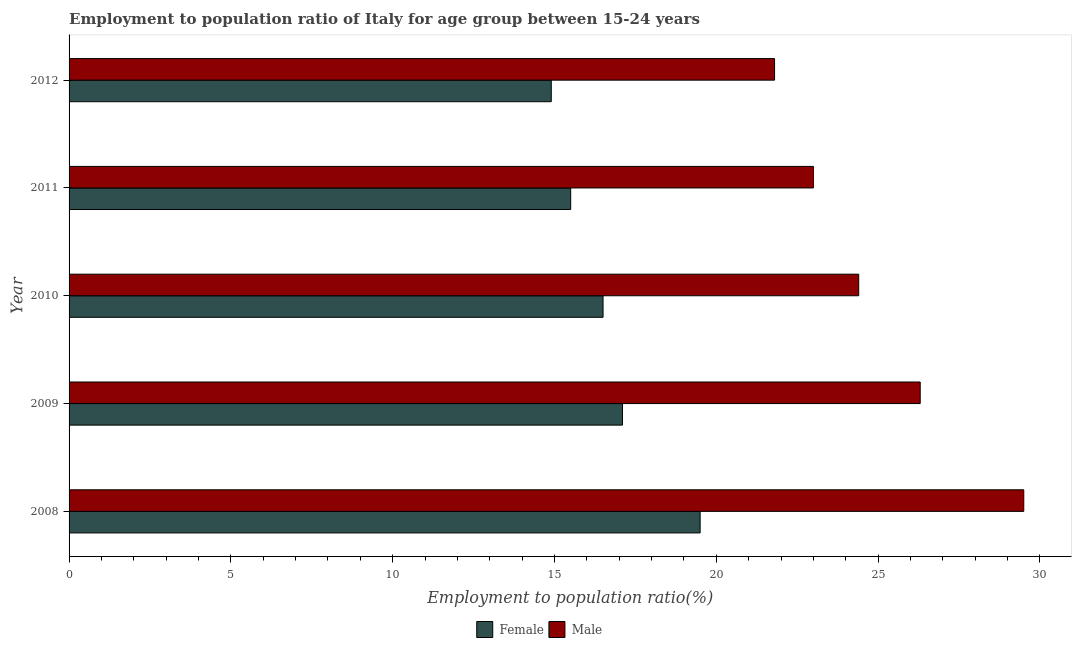How many different coloured bars are there?
Your answer should be compact. 2. How many groups of bars are there?
Your answer should be compact. 5. Are the number of bars per tick equal to the number of legend labels?
Keep it short and to the point. Yes. How many bars are there on the 1st tick from the top?
Offer a very short reply. 2. In how many cases, is the number of bars for a given year not equal to the number of legend labels?
Keep it short and to the point. 0. What is the employment to population ratio(female) in 2008?
Your response must be concise. 19.5. Across all years, what is the maximum employment to population ratio(female)?
Make the answer very short. 19.5. Across all years, what is the minimum employment to population ratio(female)?
Offer a terse response. 14.9. In which year was the employment to population ratio(male) maximum?
Offer a very short reply. 2008. What is the total employment to population ratio(female) in the graph?
Your answer should be compact. 83.5. What is the difference between the employment to population ratio(female) in 2009 and that in 2012?
Your response must be concise. 2.2. What is the difference between the employment to population ratio(female) in 2009 and the employment to population ratio(male) in 2012?
Keep it short and to the point. -4.7. What is the average employment to population ratio(female) per year?
Make the answer very short. 16.7. In the year 2011, what is the difference between the employment to population ratio(male) and employment to population ratio(female)?
Provide a succinct answer. 7.5. In how many years, is the employment to population ratio(male) greater than 16 %?
Make the answer very short. 5. What is the ratio of the employment to population ratio(male) in 2008 to that in 2011?
Your response must be concise. 1.28. Is the employment to population ratio(male) in 2009 less than that in 2012?
Make the answer very short. No. In how many years, is the employment to population ratio(female) greater than the average employment to population ratio(female) taken over all years?
Ensure brevity in your answer.  2. What does the 1st bar from the top in 2012 represents?
Ensure brevity in your answer.  Male. What does the 1st bar from the bottom in 2012 represents?
Offer a terse response. Female. How many bars are there?
Your answer should be compact. 10. Are all the bars in the graph horizontal?
Keep it short and to the point. Yes. What is the difference between two consecutive major ticks on the X-axis?
Ensure brevity in your answer.  5. Does the graph contain any zero values?
Provide a short and direct response. No. Does the graph contain grids?
Provide a succinct answer. No. How are the legend labels stacked?
Your answer should be compact. Horizontal. What is the title of the graph?
Your response must be concise. Employment to population ratio of Italy for age group between 15-24 years. Does "Private funds" appear as one of the legend labels in the graph?
Keep it short and to the point. No. What is the label or title of the Y-axis?
Your response must be concise. Year. What is the Employment to population ratio(%) in Female in 2008?
Your response must be concise. 19.5. What is the Employment to population ratio(%) of Male in 2008?
Provide a succinct answer. 29.5. What is the Employment to population ratio(%) in Female in 2009?
Ensure brevity in your answer.  17.1. What is the Employment to population ratio(%) of Male in 2009?
Provide a short and direct response. 26.3. What is the Employment to population ratio(%) of Female in 2010?
Provide a short and direct response. 16.5. What is the Employment to population ratio(%) of Male in 2010?
Keep it short and to the point. 24.4. What is the Employment to population ratio(%) of Female in 2011?
Provide a short and direct response. 15.5. What is the Employment to population ratio(%) of Male in 2011?
Provide a short and direct response. 23. What is the Employment to population ratio(%) in Female in 2012?
Your response must be concise. 14.9. What is the Employment to population ratio(%) in Male in 2012?
Your response must be concise. 21.8. Across all years, what is the maximum Employment to population ratio(%) in Female?
Your response must be concise. 19.5. Across all years, what is the maximum Employment to population ratio(%) in Male?
Your answer should be compact. 29.5. Across all years, what is the minimum Employment to population ratio(%) of Female?
Provide a succinct answer. 14.9. Across all years, what is the minimum Employment to population ratio(%) in Male?
Keep it short and to the point. 21.8. What is the total Employment to population ratio(%) of Female in the graph?
Your answer should be very brief. 83.5. What is the total Employment to population ratio(%) of Male in the graph?
Offer a very short reply. 125. What is the difference between the Employment to population ratio(%) of Male in 2008 and that in 2010?
Offer a very short reply. 5.1. What is the difference between the Employment to population ratio(%) of Male in 2008 and that in 2011?
Offer a very short reply. 6.5. What is the difference between the Employment to population ratio(%) in Female in 2009 and that in 2010?
Provide a succinct answer. 0.6. What is the difference between the Employment to population ratio(%) of Male in 2009 and that in 2010?
Keep it short and to the point. 1.9. What is the difference between the Employment to population ratio(%) in Female in 2009 and that in 2011?
Provide a succinct answer. 1.6. What is the difference between the Employment to population ratio(%) of Male in 2009 and that in 2011?
Keep it short and to the point. 3.3. What is the difference between the Employment to population ratio(%) of Male in 2010 and that in 2012?
Your answer should be very brief. 2.6. What is the difference between the Employment to population ratio(%) in Female in 2011 and that in 2012?
Ensure brevity in your answer.  0.6. What is the difference between the Employment to population ratio(%) of Female in 2008 and the Employment to population ratio(%) of Male in 2009?
Provide a succinct answer. -6.8. What is the difference between the Employment to population ratio(%) in Female in 2008 and the Employment to population ratio(%) in Male in 2010?
Provide a succinct answer. -4.9. What is the difference between the Employment to population ratio(%) of Female in 2008 and the Employment to population ratio(%) of Male in 2011?
Your answer should be very brief. -3.5. What is the difference between the Employment to population ratio(%) in Female in 2008 and the Employment to population ratio(%) in Male in 2012?
Your response must be concise. -2.3. What is the difference between the Employment to population ratio(%) of Female in 2009 and the Employment to population ratio(%) of Male in 2011?
Make the answer very short. -5.9. What is the difference between the Employment to population ratio(%) in Female in 2011 and the Employment to population ratio(%) in Male in 2012?
Ensure brevity in your answer.  -6.3. In the year 2008, what is the difference between the Employment to population ratio(%) in Female and Employment to population ratio(%) in Male?
Make the answer very short. -10. In the year 2009, what is the difference between the Employment to population ratio(%) in Female and Employment to population ratio(%) in Male?
Make the answer very short. -9.2. In the year 2011, what is the difference between the Employment to population ratio(%) of Female and Employment to population ratio(%) of Male?
Keep it short and to the point. -7.5. What is the ratio of the Employment to population ratio(%) of Female in 2008 to that in 2009?
Provide a succinct answer. 1.14. What is the ratio of the Employment to population ratio(%) in Male in 2008 to that in 2009?
Give a very brief answer. 1.12. What is the ratio of the Employment to population ratio(%) of Female in 2008 to that in 2010?
Offer a terse response. 1.18. What is the ratio of the Employment to population ratio(%) of Male in 2008 to that in 2010?
Keep it short and to the point. 1.21. What is the ratio of the Employment to population ratio(%) of Female in 2008 to that in 2011?
Your response must be concise. 1.26. What is the ratio of the Employment to population ratio(%) of Male in 2008 to that in 2011?
Your answer should be compact. 1.28. What is the ratio of the Employment to population ratio(%) of Female in 2008 to that in 2012?
Ensure brevity in your answer.  1.31. What is the ratio of the Employment to population ratio(%) of Male in 2008 to that in 2012?
Make the answer very short. 1.35. What is the ratio of the Employment to population ratio(%) of Female in 2009 to that in 2010?
Keep it short and to the point. 1.04. What is the ratio of the Employment to population ratio(%) of Male in 2009 to that in 2010?
Your answer should be compact. 1.08. What is the ratio of the Employment to population ratio(%) in Female in 2009 to that in 2011?
Ensure brevity in your answer.  1.1. What is the ratio of the Employment to population ratio(%) of Male in 2009 to that in 2011?
Keep it short and to the point. 1.14. What is the ratio of the Employment to population ratio(%) in Female in 2009 to that in 2012?
Ensure brevity in your answer.  1.15. What is the ratio of the Employment to population ratio(%) of Male in 2009 to that in 2012?
Offer a terse response. 1.21. What is the ratio of the Employment to population ratio(%) in Female in 2010 to that in 2011?
Offer a very short reply. 1.06. What is the ratio of the Employment to population ratio(%) of Male in 2010 to that in 2011?
Keep it short and to the point. 1.06. What is the ratio of the Employment to population ratio(%) of Female in 2010 to that in 2012?
Make the answer very short. 1.11. What is the ratio of the Employment to population ratio(%) in Male in 2010 to that in 2012?
Offer a very short reply. 1.12. What is the ratio of the Employment to population ratio(%) in Female in 2011 to that in 2012?
Give a very brief answer. 1.04. What is the ratio of the Employment to population ratio(%) of Male in 2011 to that in 2012?
Offer a terse response. 1.05. What is the difference between the highest and the lowest Employment to population ratio(%) in Male?
Provide a succinct answer. 7.7. 